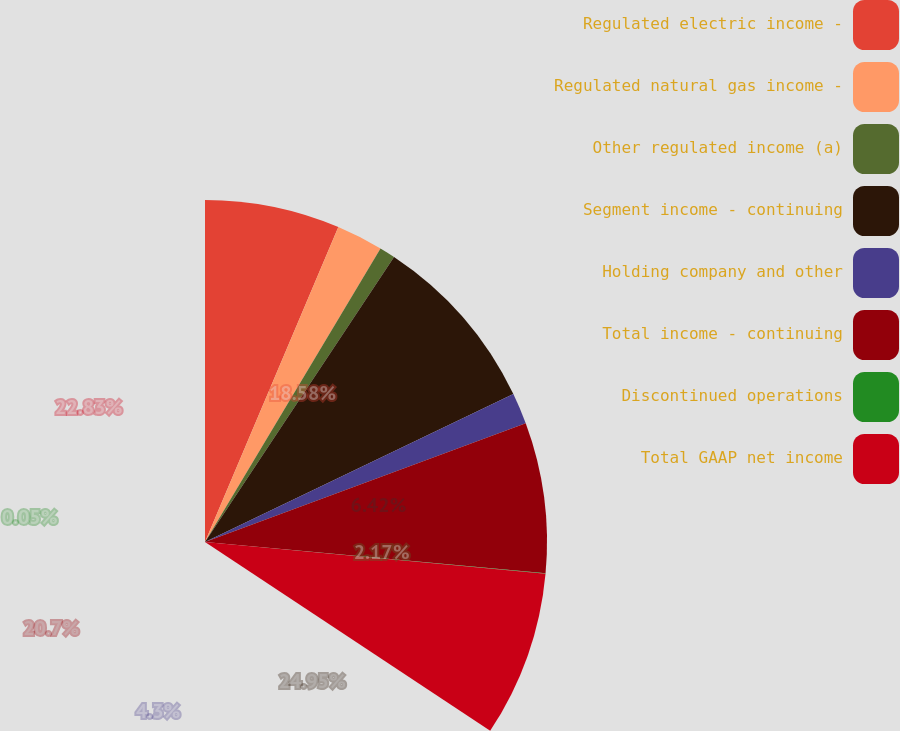Convert chart to OTSL. <chart><loc_0><loc_0><loc_500><loc_500><pie_chart><fcel>Regulated electric income -<fcel>Regulated natural gas income -<fcel>Other regulated income (a)<fcel>Segment income - continuing<fcel>Holding company and other<fcel>Total income - continuing<fcel>Discontinued operations<fcel>Total GAAP net income<nl><fcel>18.58%<fcel>6.42%<fcel>2.17%<fcel>24.95%<fcel>4.3%<fcel>20.7%<fcel>0.05%<fcel>22.83%<nl></chart> 